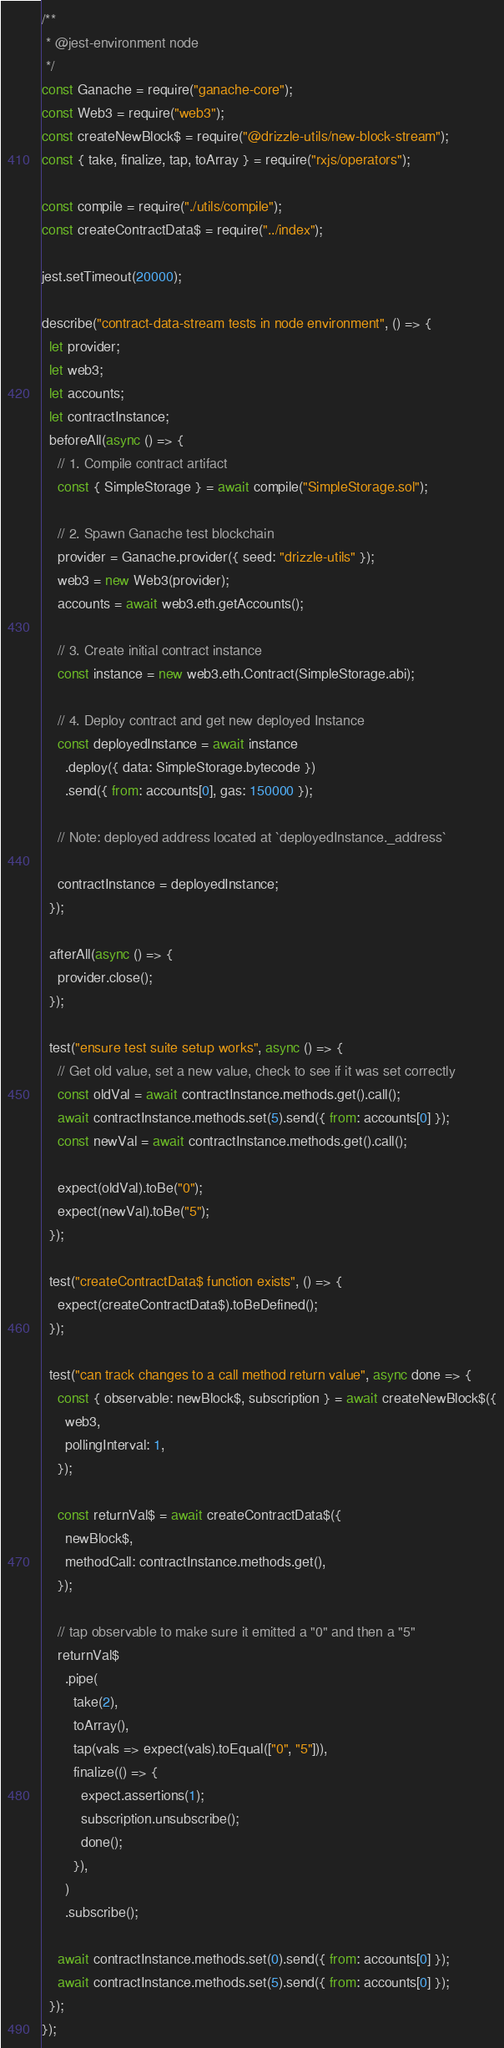<code> <loc_0><loc_0><loc_500><loc_500><_JavaScript_>/**
 * @jest-environment node
 */
const Ganache = require("ganache-core");
const Web3 = require("web3");
const createNewBlock$ = require("@drizzle-utils/new-block-stream");
const { take, finalize, tap, toArray } = require("rxjs/operators");

const compile = require("./utils/compile");
const createContractData$ = require("../index");

jest.setTimeout(20000);

describe("contract-data-stream tests in node environment", () => {
  let provider;
  let web3;
  let accounts;
  let contractInstance;
  beforeAll(async () => {
    // 1. Compile contract artifact
    const { SimpleStorage } = await compile("SimpleStorage.sol");

    // 2. Spawn Ganache test blockchain
    provider = Ganache.provider({ seed: "drizzle-utils" });
    web3 = new Web3(provider);
    accounts = await web3.eth.getAccounts();

    // 3. Create initial contract instance
    const instance = new web3.eth.Contract(SimpleStorage.abi);

    // 4. Deploy contract and get new deployed Instance
    const deployedInstance = await instance
      .deploy({ data: SimpleStorage.bytecode })
      .send({ from: accounts[0], gas: 150000 });

    // Note: deployed address located at `deployedInstance._address`

    contractInstance = deployedInstance;
  });

  afterAll(async () => {
    provider.close();
  });

  test("ensure test suite setup works", async () => {
    // Get old value, set a new value, check to see if it was set correctly
    const oldVal = await contractInstance.methods.get().call();
    await contractInstance.methods.set(5).send({ from: accounts[0] });
    const newVal = await contractInstance.methods.get().call();

    expect(oldVal).toBe("0");
    expect(newVal).toBe("5");
  });

  test("createContractData$ function exists", () => {
    expect(createContractData$).toBeDefined();
  });

  test("can track changes to a call method return value", async done => {
    const { observable: newBlock$, subscription } = await createNewBlock$({
      web3,
      pollingInterval: 1,
    });

    const returnVal$ = await createContractData$({
      newBlock$,
      methodCall: contractInstance.methods.get(),
    });

    // tap observable to make sure it emitted a "0" and then a "5"
    returnVal$
      .pipe(
        take(2),
        toArray(),
        tap(vals => expect(vals).toEqual(["0", "5"])),
        finalize(() => {
          expect.assertions(1);
          subscription.unsubscribe();
          done();
        }),
      )
      .subscribe();

    await contractInstance.methods.set(0).send({ from: accounts[0] });
    await contractInstance.methods.set(5).send({ from: accounts[0] });
  });
});
</code> 